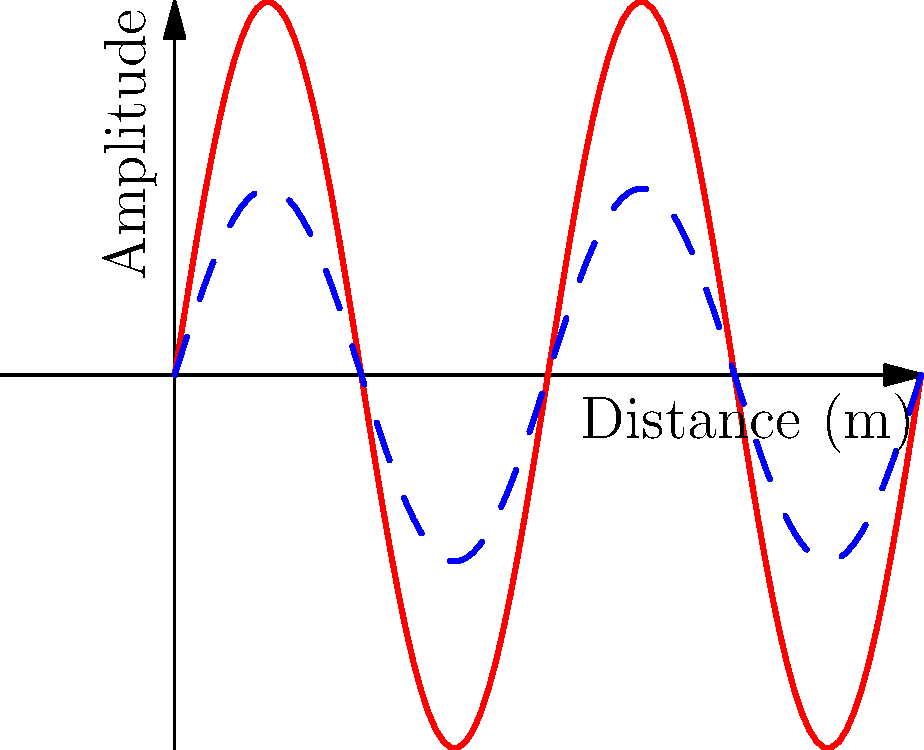In a state-of-the-art border surveillance system, sound waves are used to detect potential illegal crossings. If a sound wave with an initial amplitude of 100 dB travels 100 meters through the air and experiences an attenuation of 0.5 dB per meter, what is the final amplitude of the sound wave? How might this affect the system's ability to detect intruders? To solve this problem, we need to follow these steps:

1. Identify the initial amplitude: 100 dB
2. Determine the distance traveled: 100 meters
3. Calculate the attenuation rate: 0.5 dB per meter

Now, let's calculate the total attenuation:
Total attenuation = Distance × Attenuation rate
$$ \text{Total attenuation} = 100 \text{ m} \times 0.5 \text{ dB/m} = 50 \text{ dB} $$

To find the final amplitude, we subtract the total attenuation from the initial amplitude:
$$ \text{Final amplitude} = \text{Initial amplitude} - \text{Total attenuation} $$
$$ \text{Final amplitude} = 100 \text{ dB} - 50 \text{ dB} = 50 \text{ dB} $$

This significant reduction in amplitude could affect the system's ability to detect intruders in several ways:

1. Reduced detection range: The weaker signal might not be detectable at longer distances.
2. Increased false negatives: Some intruders might be missed due to the weaker signal.
3. Need for more sensitive equipment: To compensate for the attenuation, more advanced and costly sensors might be required.
4. Potential for environmental interference: The weaker signal could be more susceptible to background noise or weather conditions.

These factors highlight the importance of considering sound wave attenuation when designing and implementing border surveillance systems to ensure optimal security and detection capabilities.
Answer: 50 dB 